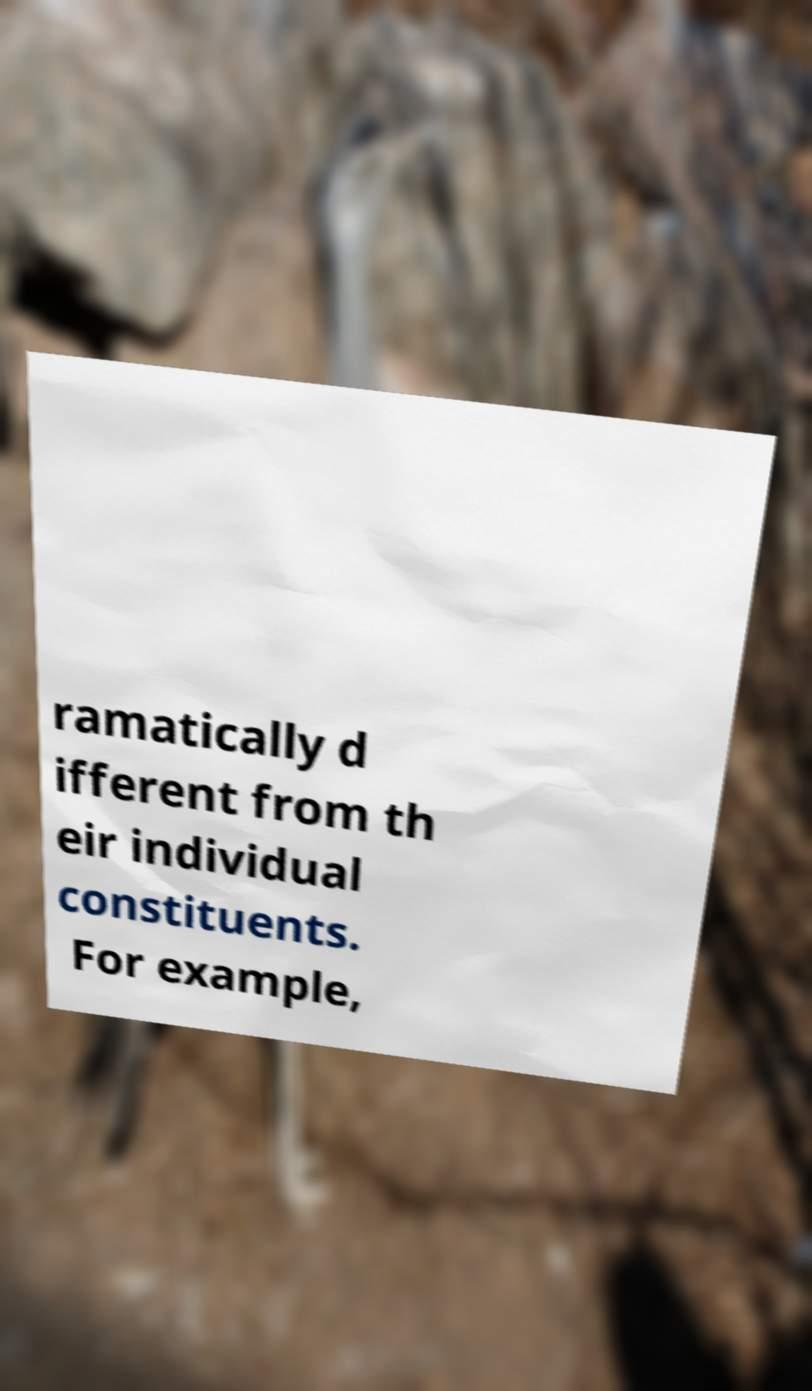Can you accurately transcribe the text from the provided image for me? ramatically d ifferent from th eir individual constituents. For example, 